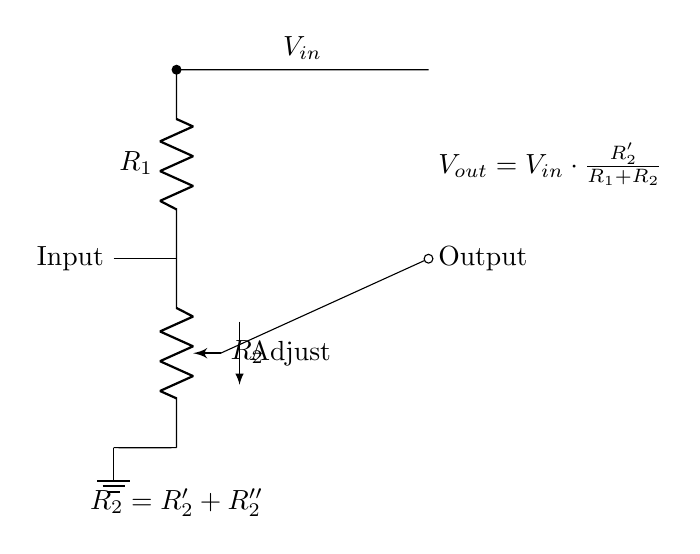What is the function of R1 in this circuit? R1 acts as a voltage divider that helps to set the input voltage level by controlling the amount of voltage that appears at the output.
Answer: Voltage divider What is the relationship between Vout and Vin? The relationship is defined by the equation Vout = Vin times the ratio of R2' to the sum of R1 and R2. This indicates that Vout is a fraction of Vin based on resistance values.
Answer: Vout = Vin * (R2' / (R1 + R2)) What does the potentiometer adjust? The potentiometer adjusts the resistance of R2, allowing for the fine-tuning of the output voltage Vout.
Answer: Output voltage How many resistors are there in total in this circuit? There are two resistors; R1 and R2, where R2 consists of two components, R2' and R2''. However, the two components of R2 are combined into one label in the circuit diagram.
Answer: Two What is the purpose of the ground connection in this circuit? The ground connection serves as a reference point for the voltage levels in the circuit, ensuring that all voltages are measured relative to this common point.
Answer: Reference point What determines the output voltage in this voltage divider? The output voltage is determined by the values of R1 and R2 (specifically R2') in relation to the input voltage Vin. The equation provided shows this dependency explicitly.
Answer: R1 and R2 values 